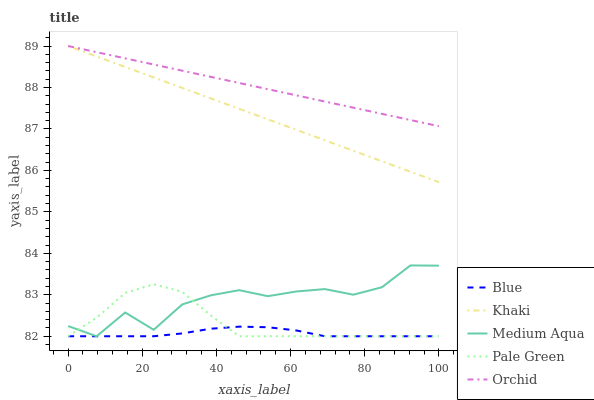Does Blue have the minimum area under the curve?
Answer yes or no. Yes. Does Orchid have the maximum area under the curve?
Answer yes or no. Yes. Does Pale Green have the minimum area under the curve?
Answer yes or no. No. Does Pale Green have the maximum area under the curve?
Answer yes or no. No. Is Khaki the smoothest?
Answer yes or no. Yes. Is Medium Aqua the roughest?
Answer yes or no. Yes. Is Pale Green the smoothest?
Answer yes or no. No. Is Pale Green the roughest?
Answer yes or no. No. Does Blue have the lowest value?
Answer yes or no. Yes. Does Khaki have the lowest value?
Answer yes or no. No. Does Orchid have the highest value?
Answer yes or no. Yes. Does Pale Green have the highest value?
Answer yes or no. No. Is Pale Green less than Orchid?
Answer yes or no. Yes. Is Orchid greater than Pale Green?
Answer yes or no. Yes. Does Pale Green intersect Medium Aqua?
Answer yes or no. Yes. Is Pale Green less than Medium Aqua?
Answer yes or no. No. Is Pale Green greater than Medium Aqua?
Answer yes or no. No. Does Pale Green intersect Orchid?
Answer yes or no. No. 